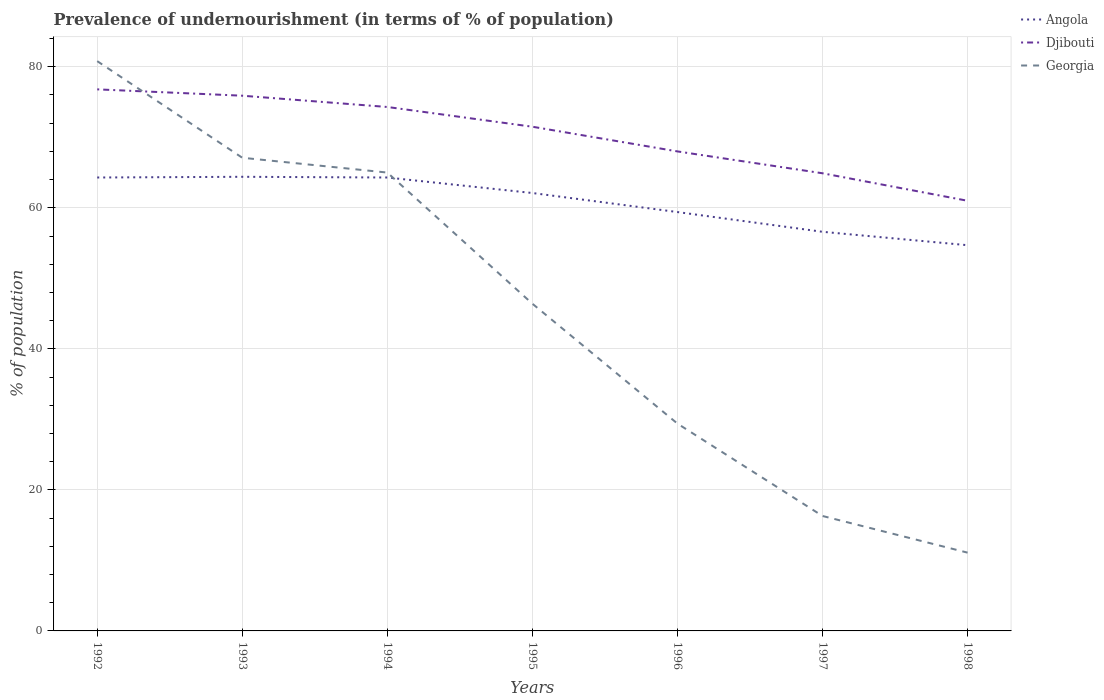Does the line corresponding to Djibouti intersect with the line corresponding to Angola?
Keep it short and to the point. No. Is the number of lines equal to the number of legend labels?
Your answer should be compact. Yes. Across all years, what is the maximum percentage of undernourished population in Djibouti?
Make the answer very short. 61. What is the total percentage of undernourished population in Djibouti in the graph?
Your response must be concise. 7.9. What is the difference between the highest and the second highest percentage of undernourished population in Georgia?
Keep it short and to the point. 69.7. Is the percentage of undernourished population in Georgia strictly greater than the percentage of undernourished population in Angola over the years?
Your response must be concise. No. What is the difference between two consecutive major ticks on the Y-axis?
Ensure brevity in your answer.  20. Are the values on the major ticks of Y-axis written in scientific E-notation?
Keep it short and to the point. No. Does the graph contain any zero values?
Ensure brevity in your answer.  No. Where does the legend appear in the graph?
Your answer should be compact. Top right. How many legend labels are there?
Provide a succinct answer. 3. What is the title of the graph?
Keep it short and to the point. Prevalence of undernourishment (in terms of % of population). What is the label or title of the Y-axis?
Your answer should be compact. % of population. What is the % of population of Angola in 1992?
Your answer should be compact. 64.3. What is the % of population in Djibouti in 1992?
Provide a short and direct response. 76.8. What is the % of population of Georgia in 1992?
Your response must be concise. 80.8. What is the % of population in Angola in 1993?
Make the answer very short. 64.4. What is the % of population in Djibouti in 1993?
Offer a very short reply. 75.9. What is the % of population of Georgia in 1993?
Keep it short and to the point. 67.1. What is the % of population in Angola in 1994?
Your answer should be very brief. 64.3. What is the % of population in Djibouti in 1994?
Ensure brevity in your answer.  74.3. What is the % of population of Georgia in 1994?
Offer a terse response. 65. What is the % of population in Angola in 1995?
Keep it short and to the point. 62.1. What is the % of population in Djibouti in 1995?
Keep it short and to the point. 71.5. What is the % of population in Georgia in 1995?
Give a very brief answer. 46.4. What is the % of population in Angola in 1996?
Offer a very short reply. 59.4. What is the % of population of Georgia in 1996?
Your answer should be compact. 29.4. What is the % of population in Angola in 1997?
Make the answer very short. 56.6. What is the % of population of Djibouti in 1997?
Offer a terse response. 64.9. What is the % of population of Angola in 1998?
Provide a succinct answer. 54.7. What is the % of population in Djibouti in 1998?
Your response must be concise. 61. What is the % of population of Georgia in 1998?
Offer a terse response. 11.1. Across all years, what is the maximum % of population in Angola?
Make the answer very short. 64.4. Across all years, what is the maximum % of population in Djibouti?
Keep it short and to the point. 76.8. Across all years, what is the maximum % of population of Georgia?
Your answer should be compact. 80.8. Across all years, what is the minimum % of population of Angola?
Your response must be concise. 54.7. Across all years, what is the minimum % of population of Georgia?
Ensure brevity in your answer.  11.1. What is the total % of population of Angola in the graph?
Provide a short and direct response. 425.8. What is the total % of population of Djibouti in the graph?
Offer a terse response. 492.4. What is the total % of population in Georgia in the graph?
Provide a succinct answer. 316.1. What is the difference between the % of population in Georgia in 1992 and that in 1993?
Your answer should be very brief. 13.7. What is the difference between the % of population in Djibouti in 1992 and that in 1994?
Give a very brief answer. 2.5. What is the difference between the % of population of Georgia in 1992 and that in 1994?
Keep it short and to the point. 15.8. What is the difference between the % of population of Georgia in 1992 and that in 1995?
Offer a very short reply. 34.4. What is the difference between the % of population of Djibouti in 1992 and that in 1996?
Your response must be concise. 8.8. What is the difference between the % of population in Georgia in 1992 and that in 1996?
Keep it short and to the point. 51.4. What is the difference between the % of population of Angola in 1992 and that in 1997?
Your answer should be compact. 7.7. What is the difference between the % of population in Djibouti in 1992 and that in 1997?
Provide a succinct answer. 11.9. What is the difference between the % of population of Georgia in 1992 and that in 1997?
Keep it short and to the point. 64.5. What is the difference between the % of population of Djibouti in 1992 and that in 1998?
Give a very brief answer. 15.8. What is the difference between the % of population of Georgia in 1992 and that in 1998?
Provide a succinct answer. 69.7. What is the difference between the % of population in Angola in 1993 and that in 1994?
Your answer should be compact. 0.1. What is the difference between the % of population of Djibouti in 1993 and that in 1994?
Ensure brevity in your answer.  1.6. What is the difference between the % of population in Georgia in 1993 and that in 1994?
Your answer should be very brief. 2.1. What is the difference between the % of population of Georgia in 1993 and that in 1995?
Make the answer very short. 20.7. What is the difference between the % of population in Angola in 1993 and that in 1996?
Offer a very short reply. 5. What is the difference between the % of population in Djibouti in 1993 and that in 1996?
Keep it short and to the point. 7.9. What is the difference between the % of population of Georgia in 1993 and that in 1996?
Provide a short and direct response. 37.7. What is the difference between the % of population in Angola in 1993 and that in 1997?
Offer a terse response. 7.8. What is the difference between the % of population in Georgia in 1993 and that in 1997?
Your answer should be compact. 50.8. What is the difference between the % of population in Djibouti in 1993 and that in 1998?
Offer a very short reply. 14.9. What is the difference between the % of population in Angola in 1994 and that in 1995?
Ensure brevity in your answer.  2.2. What is the difference between the % of population of Djibouti in 1994 and that in 1995?
Offer a very short reply. 2.8. What is the difference between the % of population in Georgia in 1994 and that in 1996?
Give a very brief answer. 35.6. What is the difference between the % of population in Angola in 1994 and that in 1997?
Provide a short and direct response. 7.7. What is the difference between the % of population in Djibouti in 1994 and that in 1997?
Your answer should be very brief. 9.4. What is the difference between the % of population of Georgia in 1994 and that in 1997?
Offer a terse response. 48.7. What is the difference between the % of population of Angola in 1994 and that in 1998?
Your answer should be very brief. 9.6. What is the difference between the % of population of Georgia in 1994 and that in 1998?
Provide a short and direct response. 53.9. What is the difference between the % of population in Georgia in 1995 and that in 1996?
Your response must be concise. 17. What is the difference between the % of population in Djibouti in 1995 and that in 1997?
Provide a succinct answer. 6.6. What is the difference between the % of population of Georgia in 1995 and that in 1997?
Your answer should be very brief. 30.1. What is the difference between the % of population of Georgia in 1995 and that in 1998?
Offer a terse response. 35.3. What is the difference between the % of population of Georgia in 1996 and that in 1997?
Your answer should be compact. 13.1. What is the difference between the % of population of Angola in 1996 and that in 1998?
Offer a very short reply. 4.7. What is the difference between the % of population in Georgia in 1996 and that in 1998?
Offer a terse response. 18.3. What is the difference between the % of population of Djibouti in 1997 and that in 1998?
Keep it short and to the point. 3.9. What is the difference between the % of population in Angola in 1992 and the % of population in Djibouti in 1993?
Keep it short and to the point. -11.6. What is the difference between the % of population in Angola in 1992 and the % of population in Georgia in 1993?
Offer a terse response. -2.8. What is the difference between the % of population in Djibouti in 1992 and the % of population in Georgia in 1994?
Your answer should be compact. 11.8. What is the difference between the % of population of Angola in 1992 and the % of population of Djibouti in 1995?
Provide a succinct answer. -7.2. What is the difference between the % of population of Angola in 1992 and the % of population of Georgia in 1995?
Make the answer very short. 17.9. What is the difference between the % of population in Djibouti in 1992 and the % of population in Georgia in 1995?
Ensure brevity in your answer.  30.4. What is the difference between the % of population of Angola in 1992 and the % of population of Djibouti in 1996?
Your answer should be very brief. -3.7. What is the difference between the % of population of Angola in 1992 and the % of population of Georgia in 1996?
Your answer should be compact. 34.9. What is the difference between the % of population of Djibouti in 1992 and the % of population of Georgia in 1996?
Keep it short and to the point. 47.4. What is the difference between the % of population of Angola in 1992 and the % of population of Djibouti in 1997?
Keep it short and to the point. -0.6. What is the difference between the % of population of Angola in 1992 and the % of population of Georgia in 1997?
Offer a very short reply. 48. What is the difference between the % of population of Djibouti in 1992 and the % of population of Georgia in 1997?
Your answer should be very brief. 60.5. What is the difference between the % of population in Angola in 1992 and the % of population in Georgia in 1998?
Give a very brief answer. 53.2. What is the difference between the % of population in Djibouti in 1992 and the % of population in Georgia in 1998?
Ensure brevity in your answer.  65.7. What is the difference between the % of population of Djibouti in 1993 and the % of population of Georgia in 1994?
Ensure brevity in your answer.  10.9. What is the difference between the % of population of Angola in 1993 and the % of population of Georgia in 1995?
Provide a short and direct response. 18. What is the difference between the % of population in Djibouti in 1993 and the % of population in Georgia in 1995?
Provide a succinct answer. 29.5. What is the difference between the % of population of Djibouti in 1993 and the % of population of Georgia in 1996?
Offer a terse response. 46.5. What is the difference between the % of population in Angola in 1993 and the % of population in Djibouti in 1997?
Offer a very short reply. -0.5. What is the difference between the % of population of Angola in 1993 and the % of population of Georgia in 1997?
Offer a terse response. 48.1. What is the difference between the % of population of Djibouti in 1993 and the % of population of Georgia in 1997?
Your answer should be compact. 59.6. What is the difference between the % of population in Angola in 1993 and the % of population in Djibouti in 1998?
Your answer should be compact. 3.4. What is the difference between the % of population in Angola in 1993 and the % of population in Georgia in 1998?
Give a very brief answer. 53.3. What is the difference between the % of population in Djibouti in 1993 and the % of population in Georgia in 1998?
Provide a succinct answer. 64.8. What is the difference between the % of population in Angola in 1994 and the % of population in Georgia in 1995?
Offer a very short reply. 17.9. What is the difference between the % of population of Djibouti in 1994 and the % of population of Georgia in 1995?
Provide a succinct answer. 27.9. What is the difference between the % of population in Angola in 1994 and the % of population in Georgia in 1996?
Offer a terse response. 34.9. What is the difference between the % of population of Djibouti in 1994 and the % of population of Georgia in 1996?
Offer a very short reply. 44.9. What is the difference between the % of population in Angola in 1994 and the % of population in Djibouti in 1997?
Offer a very short reply. -0.6. What is the difference between the % of population of Djibouti in 1994 and the % of population of Georgia in 1997?
Your response must be concise. 58. What is the difference between the % of population in Angola in 1994 and the % of population in Georgia in 1998?
Your response must be concise. 53.2. What is the difference between the % of population in Djibouti in 1994 and the % of population in Georgia in 1998?
Give a very brief answer. 63.2. What is the difference between the % of population in Angola in 1995 and the % of population in Georgia in 1996?
Make the answer very short. 32.7. What is the difference between the % of population in Djibouti in 1995 and the % of population in Georgia in 1996?
Your response must be concise. 42.1. What is the difference between the % of population of Angola in 1995 and the % of population of Georgia in 1997?
Offer a terse response. 45.8. What is the difference between the % of population of Djibouti in 1995 and the % of population of Georgia in 1997?
Your answer should be compact. 55.2. What is the difference between the % of population in Angola in 1995 and the % of population in Djibouti in 1998?
Your answer should be very brief. 1.1. What is the difference between the % of population in Angola in 1995 and the % of population in Georgia in 1998?
Your response must be concise. 51. What is the difference between the % of population of Djibouti in 1995 and the % of population of Georgia in 1998?
Provide a short and direct response. 60.4. What is the difference between the % of population of Angola in 1996 and the % of population of Djibouti in 1997?
Provide a short and direct response. -5.5. What is the difference between the % of population in Angola in 1996 and the % of population in Georgia in 1997?
Provide a short and direct response. 43.1. What is the difference between the % of population in Djibouti in 1996 and the % of population in Georgia in 1997?
Give a very brief answer. 51.7. What is the difference between the % of population of Angola in 1996 and the % of population of Djibouti in 1998?
Keep it short and to the point. -1.6. What is the difference between the % of population in Angola in 1996 and the % of population in Georgia in 1998?
Your response must be concise. 48.3. What is the difference between the % of population of Djibouti in 1996 and the % of population of Georgia in 1998?
Your answer should be very brief. 56.9. What is the difference between the % of population of Angola in 1997 and the % of population of Djibouti in 1998?
Keep it short and to the point. -4.4. What is the difference between the % of population in Angola in 1997 and the % of population in Georgia in 1998?
Your answer should be very brief. 45.5. What is the difference between the % of population in Djibouti in 1997 and the % of population in Georgia in 1998?
Give a very brief answer. 53.8. What is the average % of population of Angola per year?
Your response must be concise. 60.83. What is the average % of population of Djibouti per year?
Make the answer very short. 70.34. What is the average % of population of Georgia per year?
Your answer should be compact. 45.16. In the year 1992, what is the difference between the % of population of Angola and % of population of Georgia?
Provide a short and direct response. -16.5. In the year 1993, what is the difference between the % of population in Djibouti and % of population in Georgia?
Offer a very short reply. 8.8. In the year 1994, what is the difference between the % of population of Angola and % of population of Djibouti?
Ensure brevity in your answer.  -10. In the year 1994, what is the difference between the % of population in Angola and % of population in Georgia?
Keep it short and to the point. -0.7. In the year 1995, what is the difference between the % of population of Angola and % of population of Djibouti?
Ensure brevity in your answer.  -9.4. In the year 1995, what is the difference between the % of population of Angola and % of population of Georgia?
Keep it short and to the point. 15.7. In the year 1995, what is the difference between the % of population in Djibouti and % of population in Georgia?
Your response must be concise. 25.1. In the year 1996, what is the difference between the % of population of Angola and % of population of Georgia?
Give a very brief answer. 30. In the year 1996, what is the difference between the % of population in Djibouti and % of population in Georgia?
Offer a very short reply. 38.6. In the year 1997, what is the difference between the % of population in Angola and % of population in Djibouti?
Your answer should be very brief. -8.3. In the year 1997, what is the difference between the % of population of Angola and % of population of Georgia?
Provide a succinct answer. 40.3. In the year 1997, what is the difference between the % of population of Djibouti and % of population of Georgia?
Offer a terse response. 48.6. In the year 1998, what is the difference between the % of population in Angola and % of population in Georgia?
Keep it short and to the point. 43.6. In the year 1998, what is the difference between the % of population of Djibouti and % of population of Georgia?
Give a very brief answer. 49.9. What is the ratio of the % of population in Djibouti in 1992 to that in 1993?
Keep it short and to the point. 1.01. What is the ratio of the % of population of Georgia in 1992 to that in 1993?
Your answer should be compact. 1.2. What is the ratio of the % of population in Djibouti in 1992 to that in 1994?
Keep it short and to the point. 1.03. What is the ratio of the % of population of Georgia in 1992 to that in 1994?
Keep it short and to the point. 1.24. What is the ratio of the % of population in Angola in 1992 to that in 1995?
Make the answer very short. 1.04. What is the ratio of the % of population of Djibouti in 1992 to that in 1995?
Give a very brief answer. 1.07. What is the ratio of the % of population in Georgia in 1992 to that in 1995?
Offer a very short reply. 1.74. What is the ratio of the % of population of Angola in 1992 to that in 1996?
Your response must be concise. 1.08. What is the ratio of the % of population in Djibouti in 1992 to that in 1996?
Ensure brevity in your answer.  1.13. What is the ratio of the % of population of Georgia in 1992 to that in 1996?
Your answer should be very brief. 2.75. What is the ratio of the % of population in Angola in 1992 to that in 1997?
Offer a very short reply. 1.14. What is the ratio of the % of population of Djibouti in 1992 to that in 1997?
Make the answer very short. 1.18. What is the ratio of the % of population of Georgia in 1992 to that in 1997?
Give a very brief answer. 4.96. What is the ratio of the % of population in Angola in 1992 to that in 1998?
Provide a succinct answer. 1.18. What is the ratio of the % of population in Djibouti in 1992 to that in 1998?
Provide a short and direct response. 1.26. What is the ratio of the % of population in Georgia in 1992 to that in 1998?
Your answer should be compact. 7.28. What is the ratio of the % of population of Angola in 1993 to that in 1994?
Make the answer very short. 1. What is the ratio of the % of population in Djibouti in 1993 to that in 1994?
Offer a terse response. 1.02. What is the ratio of the % of population in Georgia in 1993 to that in 1994?
Provide a succinct answer. 1.03. What is the ratio of the % of population in Angola in 1993 to that in 1995?
Ensure brevity in your answer.  1.04. What is the ratio of the % of population in Djibouti in 1993 to that in 1995?
Offer a very short reply. 1.06. What is the ratio of the % of population of Georgia in 1993 to that in 1995?
Offer a very short reply. 1.45. What is the ratio of the % of population of Angola in 1993 to that in 1996?
Provide a succinct answer. 1.08. What is the ratio of the % of population of Djibouti in 1993 to that in 1996?
Offer a terse response. 1.12. What is the ratio of the % of population of Georgia in 1993 to that in 1996?
Your answer should be compact. 2.28. What is the ratio of the % of population of Angola in 1993 to that in 1997?
Give a very brief answer. 1.14. What is the ratio of the % of population in Djibouti in 1993 to that in 1997?
Keep it short and to the point. 1.17. What is the ratio of the % of population in Georgia in 1993 to that in 1997?
Offer a terse response. 4.12. What is the ratio of the % of population in Angola in 1993 to that in 1998?
Make the answer very short. 1.18. What is the ratio of the % of population in Djibouti in 1993 to that in 1998?
Make the answer very short. 1.24. What is the ratio of the % of population in Georgia in 1993 to that in 1998?
Provide a short and direct response. 6.04. What is the ratio of the % of population in Angola in 1994 to that in 1995?
Give a very brief answer. 1.04. What is the ratio of the % of population in Djibouti in 1994 to that in 1995?
Make the answer very short. 1.04. What is the ratio of the % of population in Georgia in 1994 to that in 1995?
Provide a short and direct response. 1.4. What is the ratio of the % of population in Angola in 1994 to that in 1996?
Your response must be concise. 1.08. What is the ratio of the % of population in Djibouti in 1994 to that in 1996?
Offer a terse response. 1.09. What is the ratio of the % of population in Georgia in 1994 to that in 1996?
Your answer should be compact. 2.21. What is the ratio of the % of population in Angola in 1994 to that in 1997?
Your answer should be compact. 1.14. What is the ratio of the % of population of Djibouti in 1994 to that in 1997?
Your answer should be very brief. 1.14. What is the ratio of the % of population in Georgia in 1994 to that in 1997?
Provide a succinct answer. 3.99. What is the ratio of the % of population of Angola in 1994 to that in 1998?
Keep it short and to the point. 1.18. What is the ratio of the % of population in Djibouti in 1994 to that in 1998?
Provide a succinct answer. 1.22. What is the ratio of the % of population of Georgia in 1994 to that in 1998?
Your answer should be compact. 5.86. What is the ratio of the % of population of Angola in 1995 to that in 1996?
Ensure brevity in your answer.  1.05. What is the ratio of the % of population of Djibouti in 1995 to that in 1996?
Offer a terse response. 1.05. What is the ratio of the % of population of Georgia in 1995 to that in 1996?
Make the answer very short. 1.58. What is the ratio of the % of population in Angola in 1995 to that in 1997?
Ensure brevity in your answer.  1.1. What is the ratio of the % of population of Djibouti in 1995 to that in 1997?
Give a very brief answer. 1.1. What is the ratio of the % of population of Georgia in 1995 to that in 1997?
Make the answer very short. 2.85. What is the ratio of the % of population in Angola in 1995 to that in 1998?
Your response must be concise. 1.14. What is the ratio of the % of population in Djibouti in 1995 to that in 1998?
Keep it short and to the point. 1.17. What is the ratio of the % of population of Georgia in 1995 to that in 1998?
Make the answer very short. 4.18. What is the ratio of the % of population of Angola in 1996 to that in 1997?
Give a very brief answer. 1.05. What is the ratio of the % of population in Djibouti in 1996 to that in 1997?
Provide a short and direct response. 1.05. What is the ratio of the % of population in Georgia in 1996 to that in 1997?
Provide a short and direct response. 1.8. What is the ratio of the % of population of Angola in 1996 to that in 1998?
Your answer should be very brief. 1.09. What is the ratio of the % of population of Djibouti in 1996 to that in 1998?
Offer a terse response. 1.11. What is the ratio of the % of population of Georgia in 1996 to that in 1998?
Offer a very short reply. 2.65. What is the ratio of the % of population of Angola in 1997 to that in 1998?
Your answer should be very brief. 1.03. What is the ratio of the % of population in Djibouti in 1997 to that in 1998?
Ensure brevity in your answer.  1.06. What is the ratio of the % of population in Georgia in 1997 to that in 1998?
Ensure brevity in your answer.  1.47. What is the difference between the highest and the second highest % of population of Djibouti?
Make the answer very short. 0.9. What is the difference between the highest and the lowest % of population of Angola?
Your answer should be very brief. 9.7. What is the difference between the highest and the lowest % of population in Georgia?
Keep it short and to the point. 69.7. 